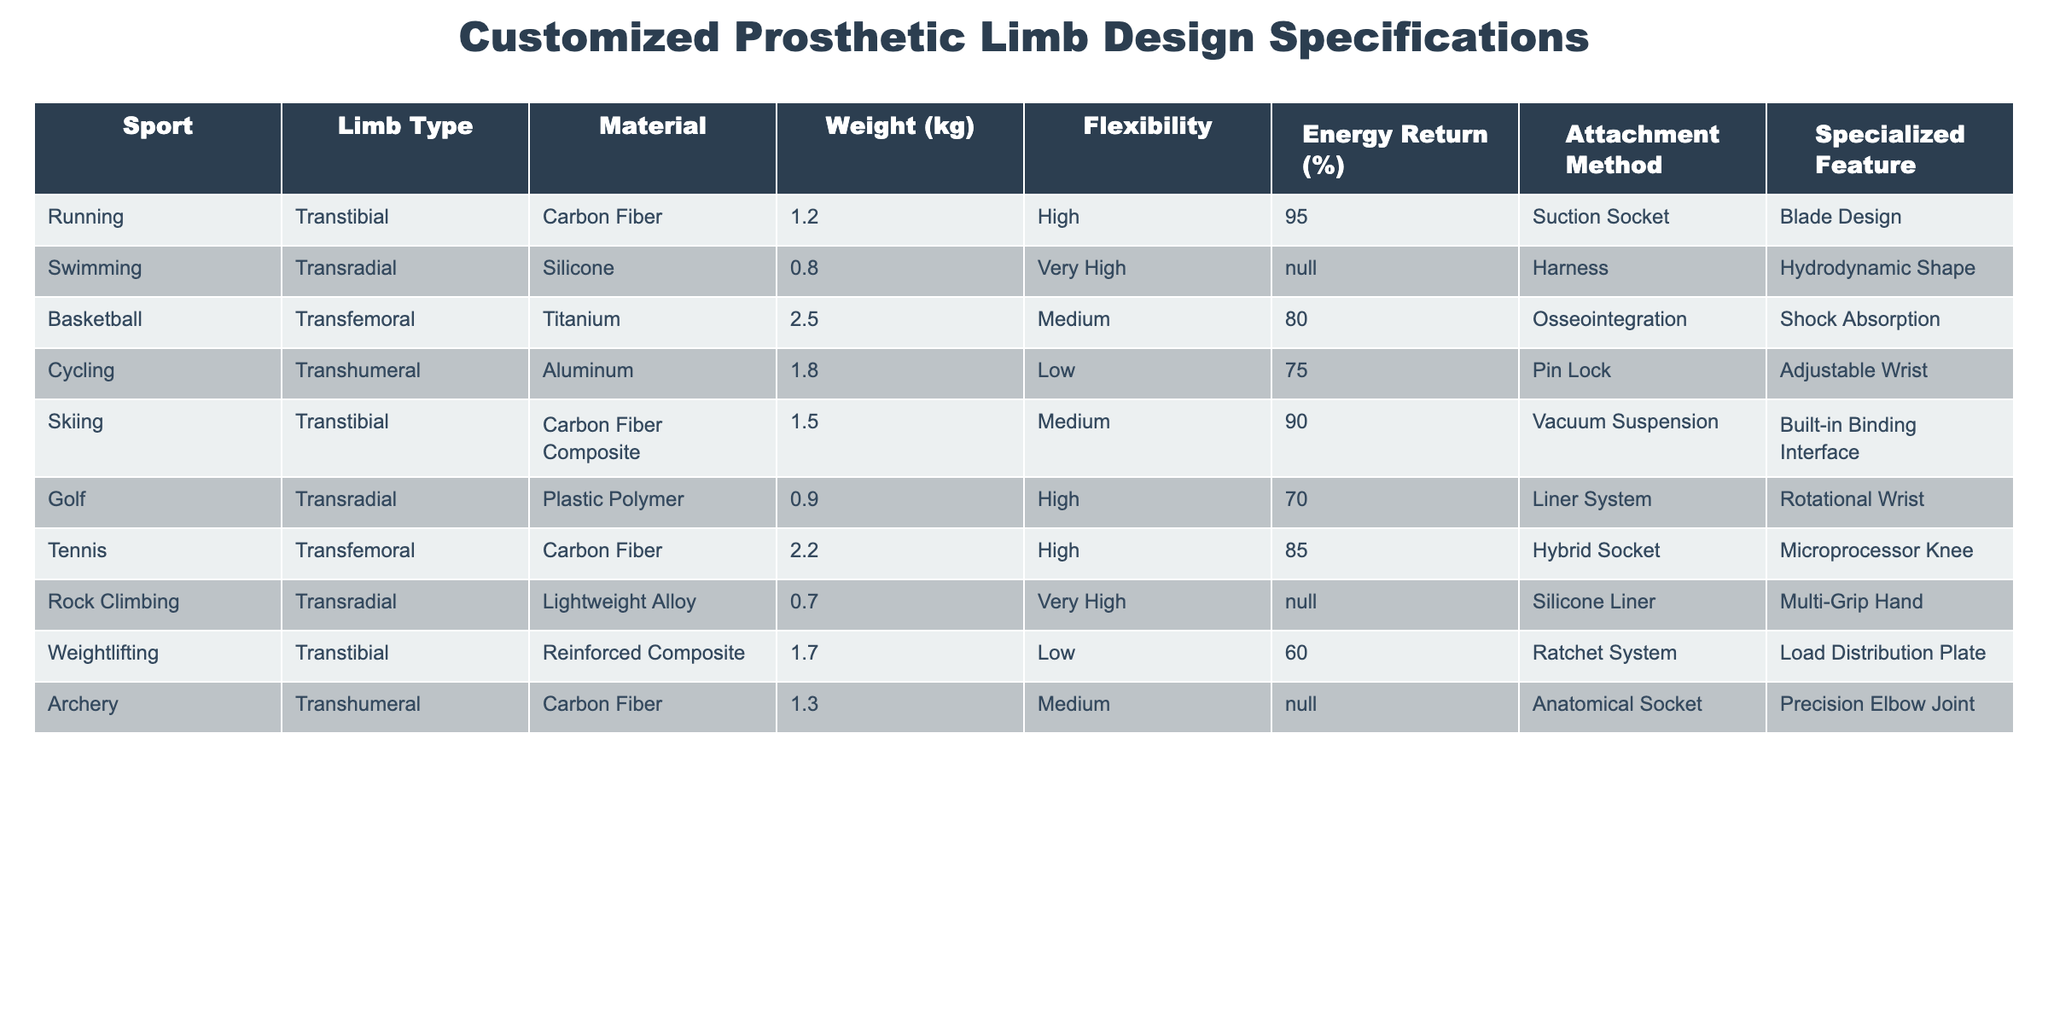What is the weight of the basketball prosthetic limb? The table indicates that the weight of the basketball prosthetic limb, which is of the transfemoral type, is listed as 2.5 kg.
Answer: 2.5 kg Which limb types have very high flexibility? By examining the table, the limb types that have very high flexibility are transradial for swimming and rock climbing.
Answer: Transradial (swimming, rock climbing) What material is used for the cycling prosthetic limb? The table shows that the material used for the cycling prosthetic limb, a transhumeral type, is aluminum.
Answer: Aluminum Is the energy return for the golf limb design higher than that of the weightlifting limb design? The energy return for the golf limb is listed as 70%, while for the weightlifting limb it is 60%. Thus, the golf limb has a higher energy return.
Answer: Yes What is the average weight of the transtibial limb designs listed in the table? The weights of the transtibial limbs are 1.2 kg (running) and 1.5 kg (skiing). To find the average, we sum them up: 1.2 + 1.5 = 2.7 kg. There are 2 limbs, so the average weight is 2.7 / 2 = 1.35 kg.
Answer: 1.35 kg Which sport has the lowest weight for its prosthetic limb? By comparing the weights listed in the table, rock climbing has the lowest weight of 0.7 kg for its transradial limb.
Answer: Rock climbing Are there any prosthetic limbs in the table that use a silicone material? The table shows that the swimming limb is made of silicone. Thus, there is at least one limb using silicone material.
Answer: Yes What is the difference in energy return between the skiing and basketball limb designs? The energy return for the skiing limb is 90%, while for the basketball limb it is 80%. The difference can be calculated as 90 - 80 = 10%. Thus, the skiing limb design has a 10% higher energy return.
Answer: 10% Which specialized feature is unique to the weightlifting prosthetic limb? The specialized feature listed for the weightlifting limb design is the load distribution plate, which is not mentioned for any other limb in the table.
Answer: Load distribution plate 